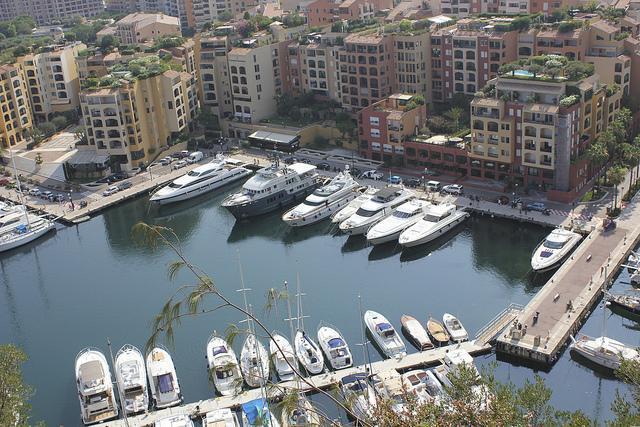How many boats are in the picture?
Give a very brief answer. 4. How many horses with a white stomach are there?
Give a very brief answer. 0. 